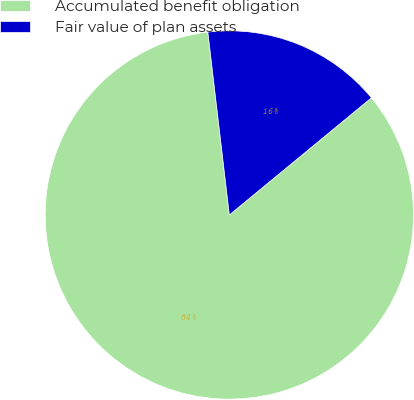Convert chart to OTSL. <chart><loc_0><loc_0><loc_500><loc_500><pie_chart><fcel>Accumulated benefit obligation<fcel>Fair value of plan assets<nl><fcel>84.11%<fcel>15.89%<nl></chart> 